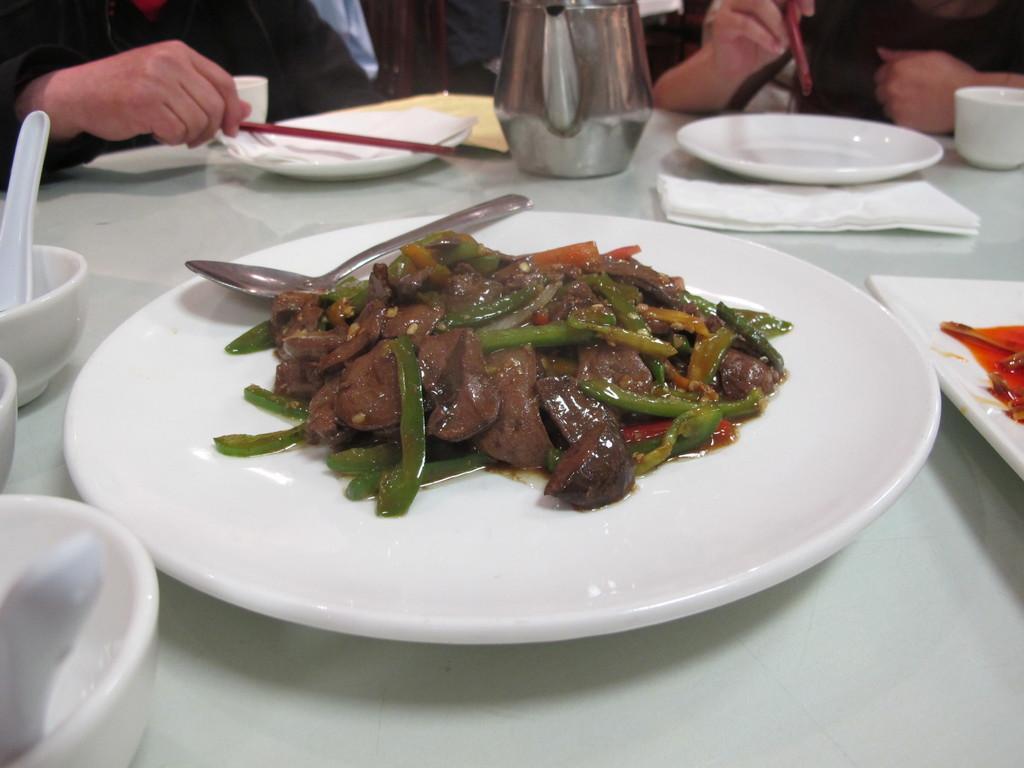How would you summarize this image in a sentence or two? In the picture I can see people and a white color table. On the table I can see food items in a plate, spoons, white color plates, bowls, tissue papers and some other objects. 